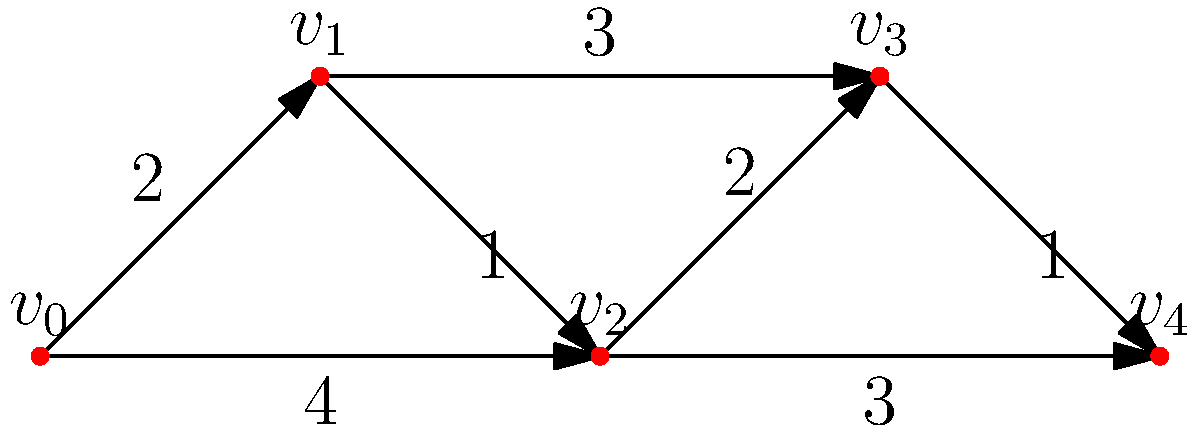In the context of critical infrastructure protection, consider the above network where nodes represent key facilities and edges represent secure communication channels with associated transmission times (in minutes). What is the shortest time required to transmit a crucial national security alert from facility $v_0$ to facility $v_4$? To find the shortest path between $v_0$ and $v_4$, we'll use Dijkstra's algorithm:

1. Initialize:
   - Set distance to $v_0$ as 0, all others as infinity.
   - Set all nodes as unvisited.

2. For the current node (starting with $v_0$), consider all unvisited neighbors and calculate their tentative distances.

3. When we're done considering all neighbors of the current node, mark it as visited.

4. If the destination node ($v_4$) has been marked visited, we're done. Otherwise, select the unvisited node with the smallest tentative distance and set it as the new current node. Go back to step 2.

Applying the algorithm:

- Start at $v_0$: Update $v_1$ (2) and $v_2$ (4)
- Visit $v_1$: Update $v_2$ (2+1=3), $v_3$ (2+3=5)
- Visit $v_2$: Update $v_3$ (3+2=5), $v_4$ (3+3=6)
- Visit $v_3$: Update $v_4$ (5+1=6)
- Visit $v_4$: Done

The shortest path is $v_0 \rightarrow v_1 \rightarrow v_2 \rightarrow v_4$ with a total time of 6 minutes.
Answer: 6 minutes 